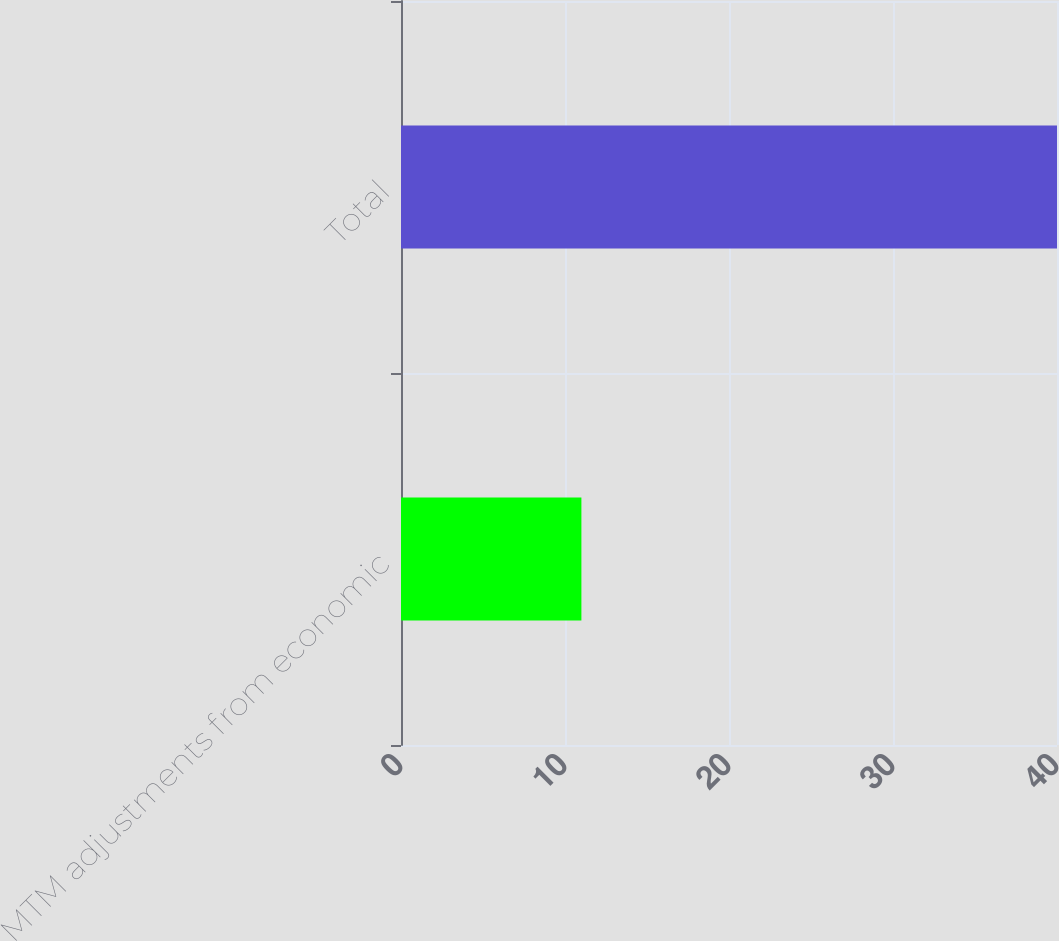Convert chart to OTSL. <chart><loc_0><loc_0><loc_500><loc_500><bar_chart><fcel>MTM adjustments from economic<fcel>Total<nl><fcel>11<fcel>40<nl></chart> 